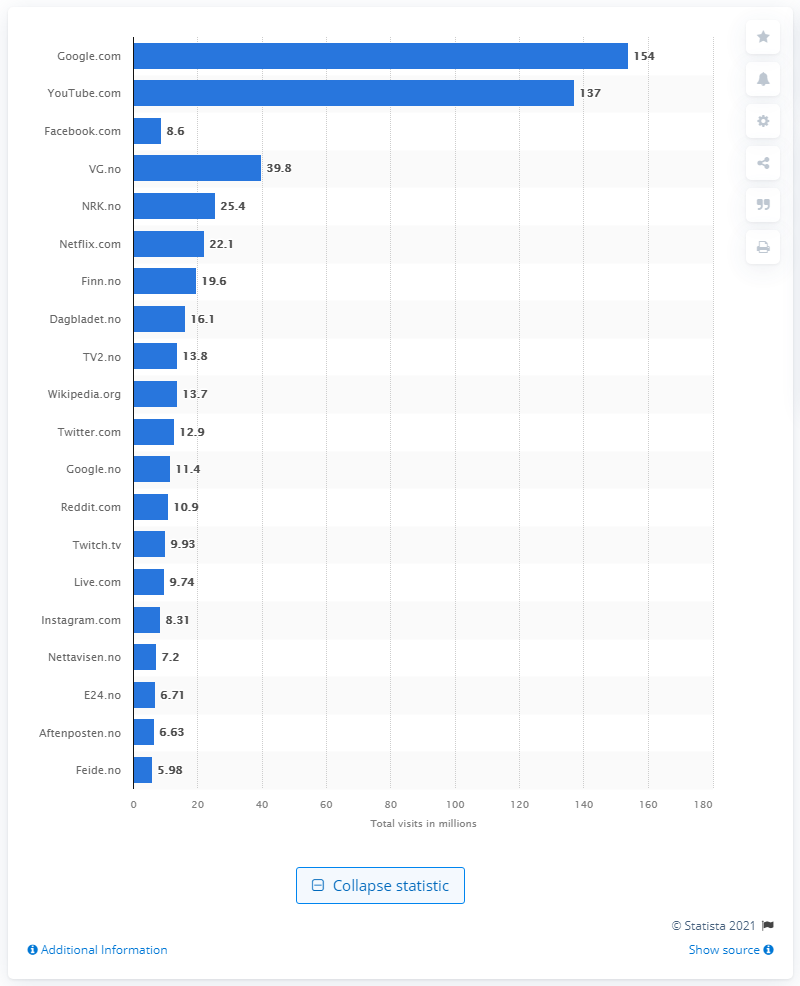Indicate a few pertinent items in this graphic. In Norway, Google.com received an average of 154 monthly visits. 